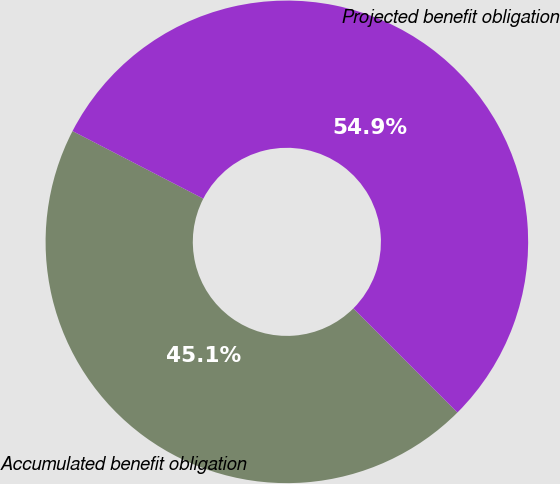<chart> <loc_0><loc_0><loc_500><loc_500><pie_chart><fcel>Accumulated benefit obligation<fcel>Projected benefit obligation<nl><fcel>45.09%<fcel>54.91%<nl></chart> 